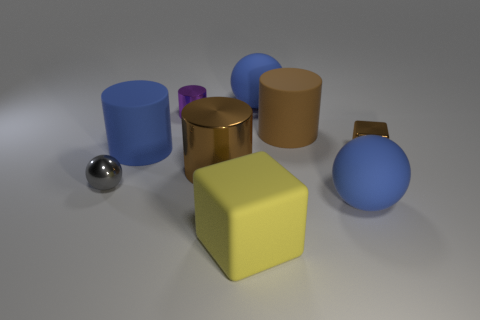Are there more large yellow rubber cubes than blue things?
Your response must be concise. No. What number of things are either brown metal things to the right of the large yellow block or things that are to the right of the large blue matte cylinder?
Keep it short and to the point. 7. The ball that is the same size as the purple metallic thing is what color?
Provide a succinct answer. Gray. Does the yellow block have the same material as the tiny purple cylinder?
Make the answer very short. No. The small thing behind the large blue thing on the left side of the big yellow thing is made of what material?
Your answer should be very brief. Metal. Is the number of brown things left of the small ball greater than the number of cyan metal cubes?
Your answer should be compact. No. How many other things are the same size as the blue cylinder?
Ensure brevity in your answer.  5. Is the big metallic cylinder the same color as the tiny block?
Offer a very short reply. Yes. There is a small thing that is to the right of the thing in front of the large thing on the right side of the large brown rubber object; what color is it?
Your response must be concise. Brown. How many gray balls are behind the purple metal thing that is behind the brown block that is right of the small purple shiny cylinder?
Your answer should be compact. 0. 